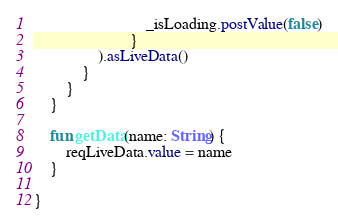Convert code to text. <code><loc_0><loc_0><loc_500><loc_500><_Kotlin_>                            _isLoading.postValue(false)
                        }
                ).asLiveData()
            }
        }
    }

    fun getData(name: String) {
        reqLiveData.value = name
    }

}</code> 